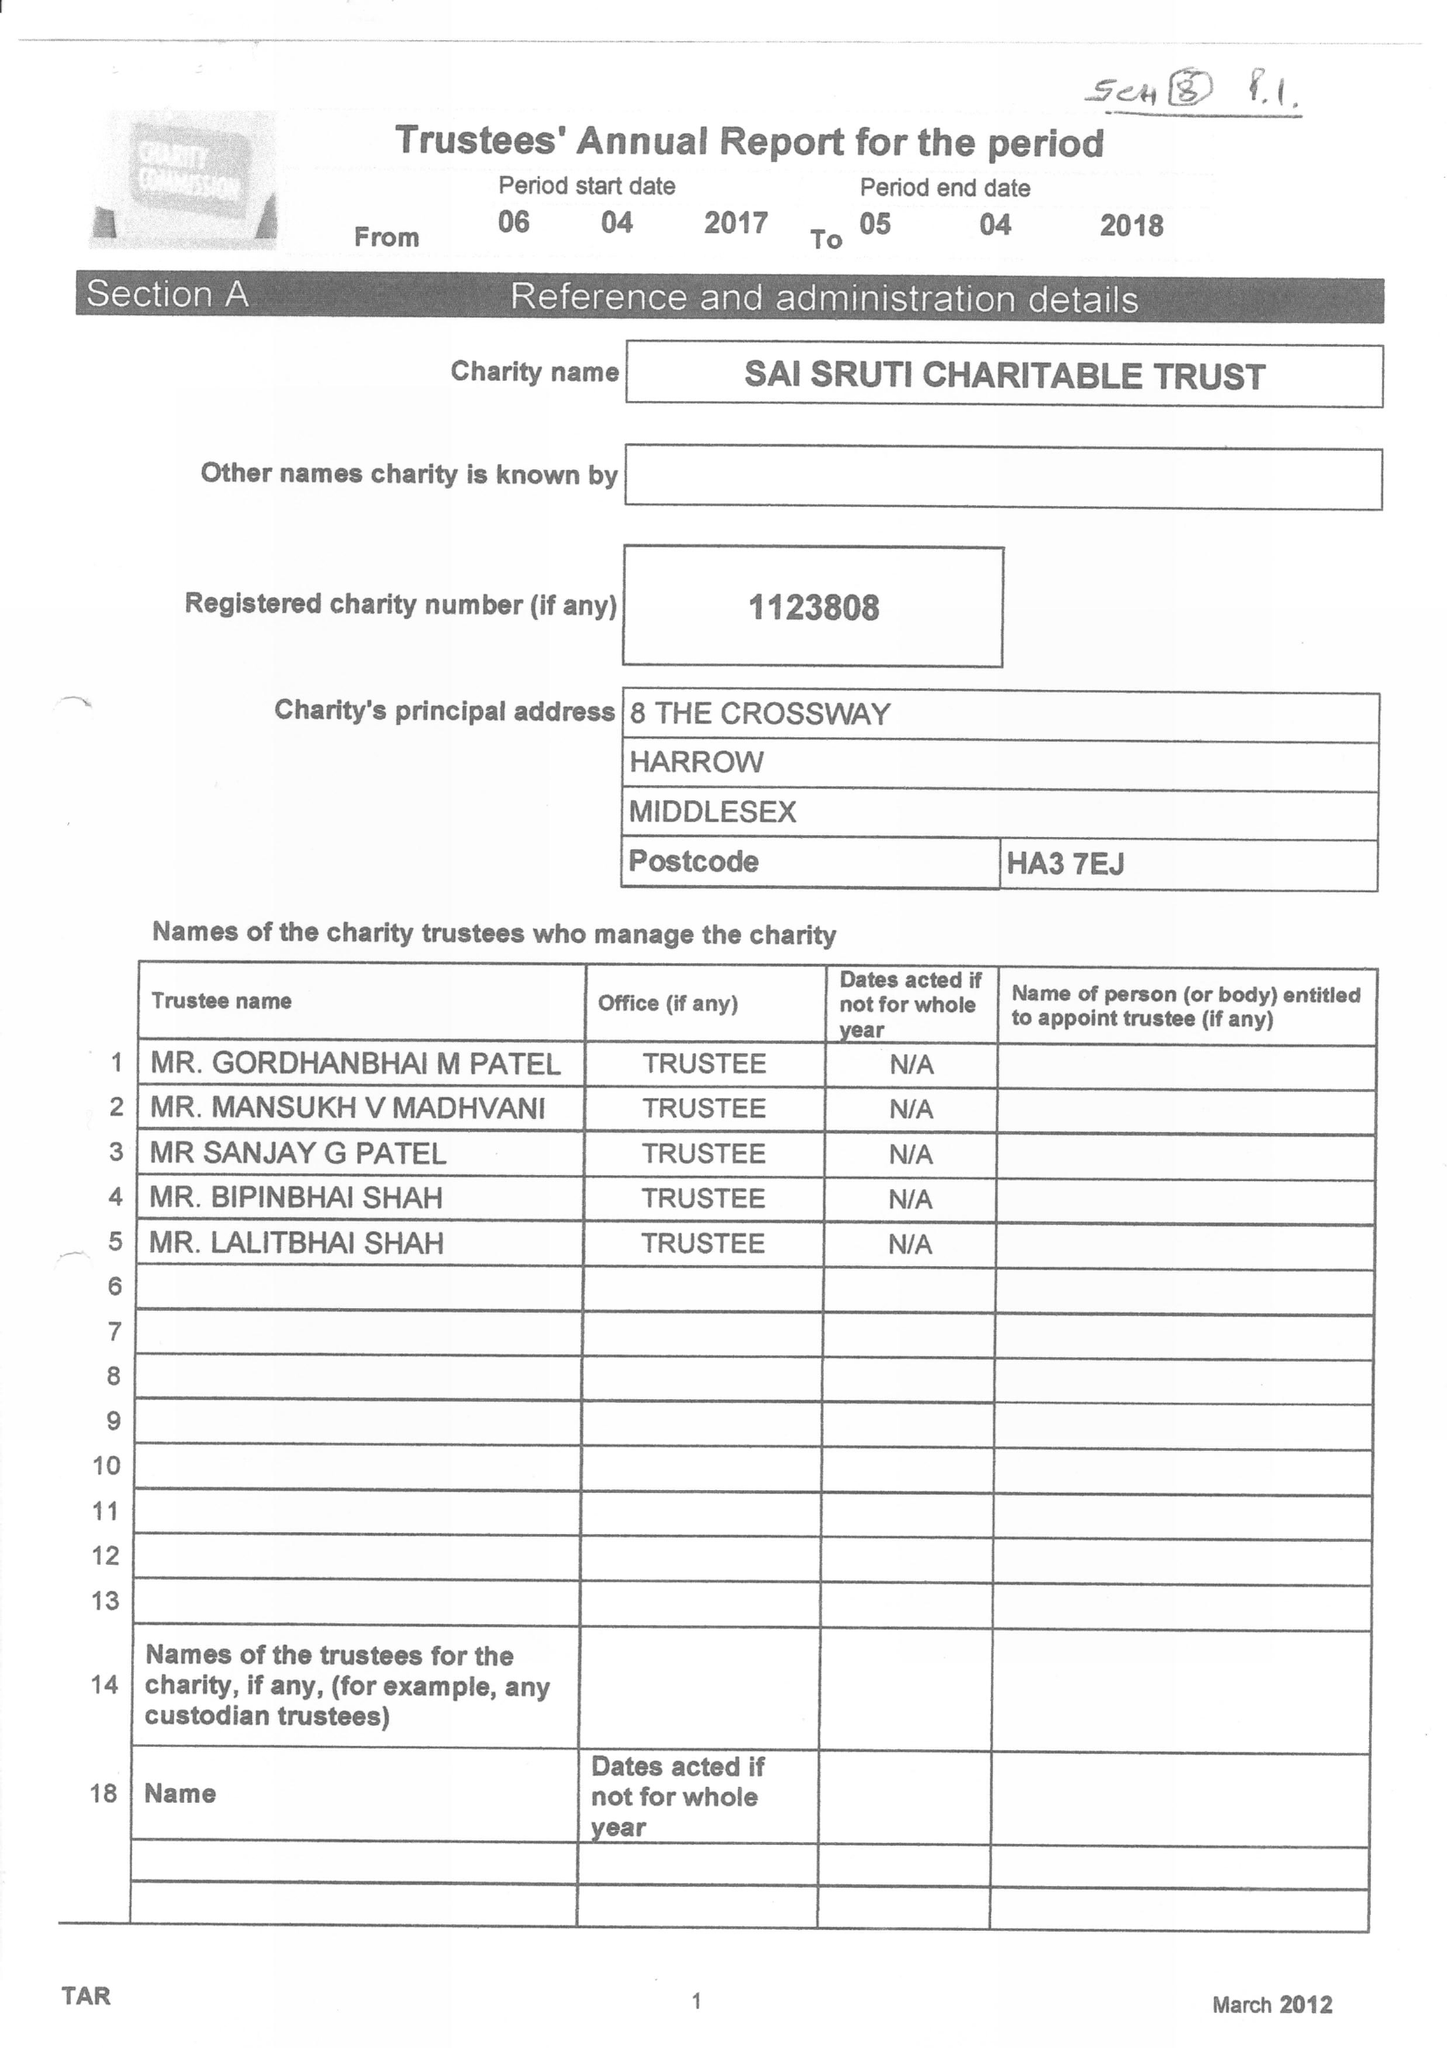What is the value for the address__post_town?
Answer the question using a single word or phrase. HARROW 